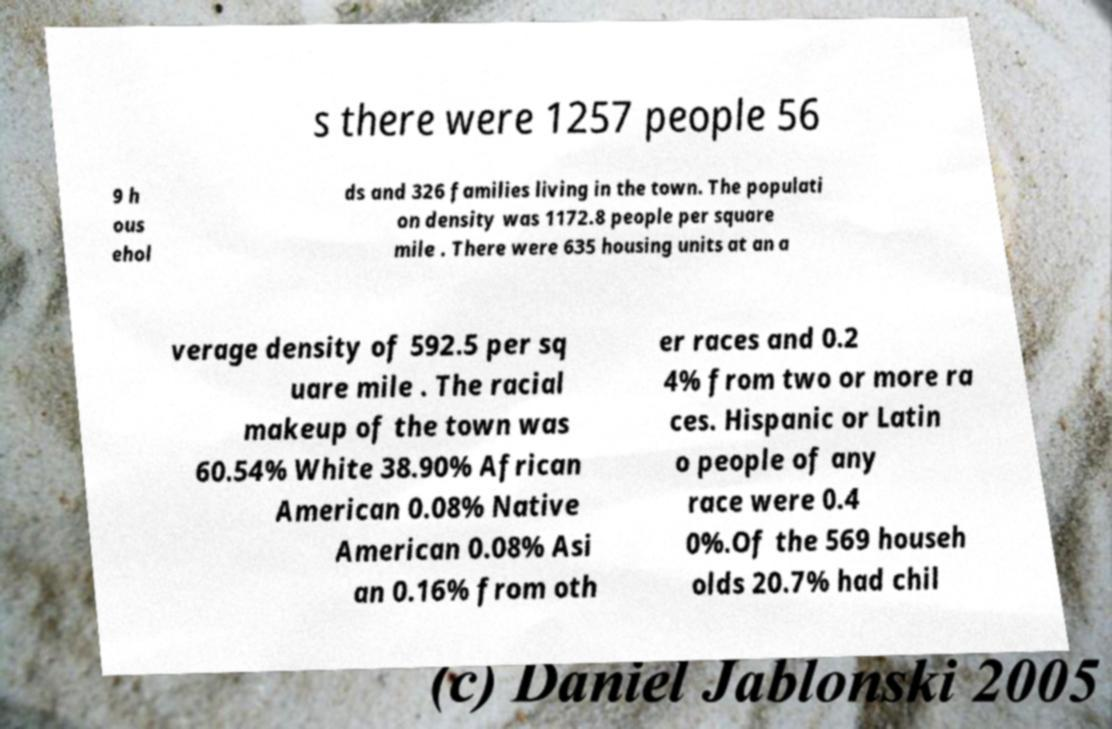There's text embedded in this image that I need extracted. Can you transcribe it verbatim? s there were 1257 people 56 9 h ous ehol ds and 326 families living in the town. The populati on density was 1172.8 people per square mile . There were 635 housing units at an a verage density of 592.5 per sq uare mile . The racial makeup of the town was 60.54% White 38.90% African American 0.08% Native American 0.08% Asi an 0.16% from oth er races and 0.2 4% from two or more ra ces. Hispanic or Latin o people of any race were 0.4 0%.Of the 569 househ olds 20.7% had chil 